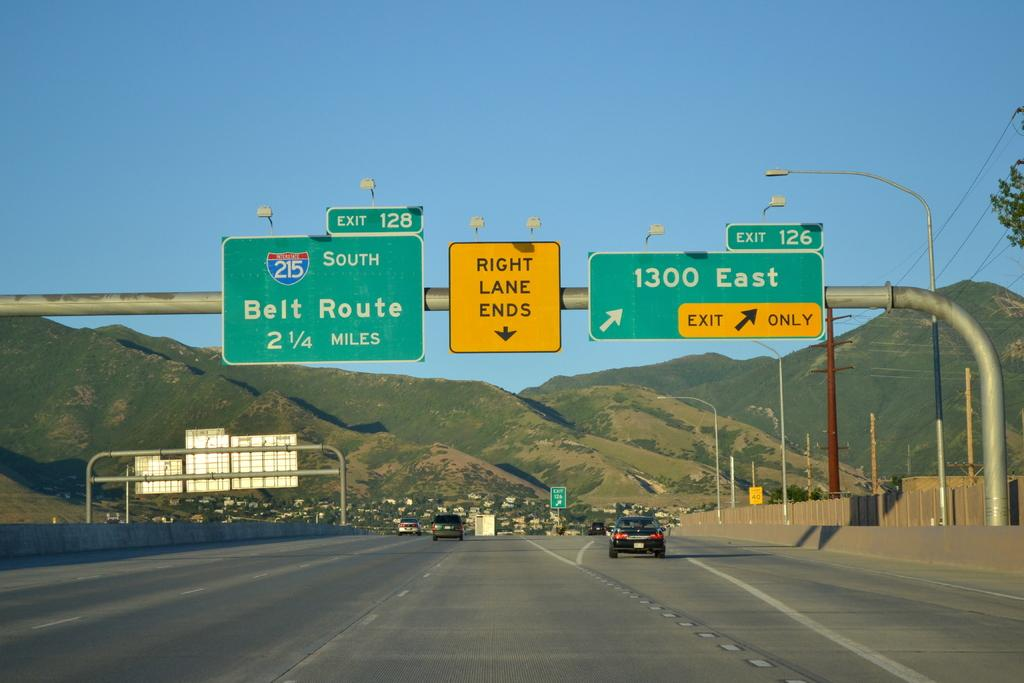Provide a one-sentence caption for the provided image. hifhway signs for exit 128 south to belt route or 1300 east exit 126. 